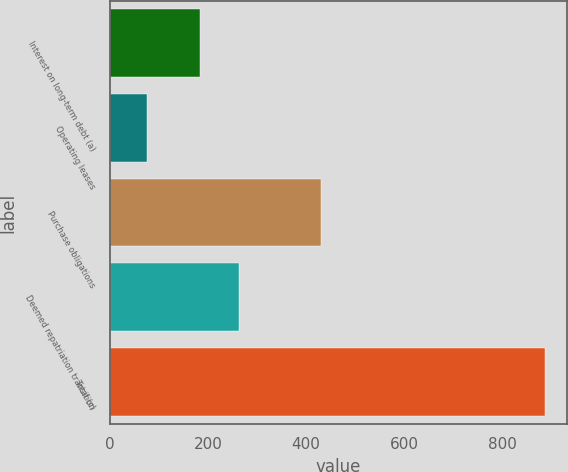<chart> <loc_0><loc_0><loc_500><loc_500><bar_chart><fcel>Interest on long-term debt (a)<fcel>Operating leases<fcel>Purchase obligations<fcel>Deemed repatriation transition<fcel>Total (c)<nl><fcel>183<fcel>77<fcel>430<fcel>263.9<fcel>886<nl></chart> 